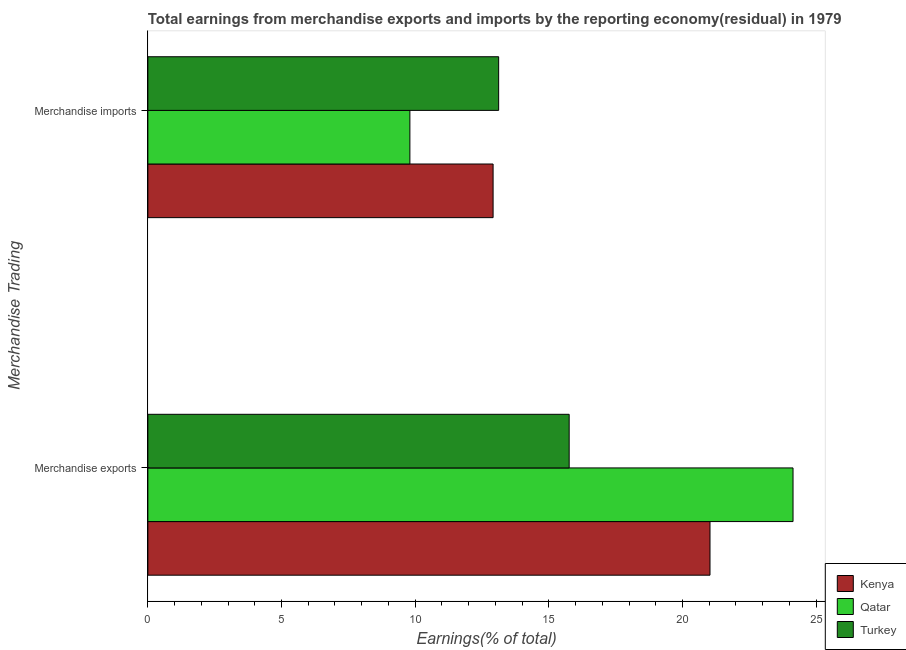How many different coloured bars are there?
Provide a succinct answer. 3. How many groups of bars are there?
Provide a succinct answer. 2. How many bars are there on the 1st tick from the top?
Make the answer very short. 3. What is the earnings from merchandise exports in Qatar?
Your answer should be compact. 24.14. Across all countries, what is the maximum earnings from merchandise imports?
Offer a very short reply. 13.12. Across all countries, what is the minimum earnings from merchandise exports?
Your answer should be very brief. 15.76. In which country was the earnings from merchandise exports maximum?
Offer a terse response. Qatar. In which country was the earnings from merchandise imports minimum?
Keep it short and to the point. Qatar. What is the total earnings from merchandise imports in the graph?
Your response must be concise. 35.84. What is the difference between the earnings from merchandise exports in Turkey and that in Kenya?
Your answer should be very brief. -5.27. What is the difference between the earnings from merchandise exports in Turkey and the earnings from merchandise imports in Qatar?
Make the answer very short. 5.96. What is the average earnings from merchandise exports per country?
Your answer should be very brief. 20.31. What is the difference between the earnings from merchandise exports and earnings from merchandise imports in Qatar?
Provide a succinct answer. 14.33. What is the ratio of the earnings from merchandise exports in Kenya to that in Qatar?
Your answer should be compact. 0.87. In how many countries, is the earnings from merchandise exports greater than the average earnings from merchandise exports taken over all countries?
Offer a terse response. 2. What does the 3rd bar from the top in Merchandise imports represents?
Make the answer very short. Kenya. What does the 3rd bar from the bottom in Merchandise imports represents?
Provide a short and direct response. Turkey. How many countries are there in the graph?
Give a very brief answer. 3. What is the difference between two consecutive major ticks on the X-axis?
Your response must be concise. 5. How are the legend labels stacked?
Keep it short and to the point. Vertical. What is the title of the graph?
Keep it short and to the point. Total earnings from merchandise exports and imports by the reporting economy(residual) in 1979. Does "Sub-Saharan Africa (developing only)" appear as one of the legend labels in the graph?
Your answer should be compact. No. What is the label or title of the X-axis?
Your answer should be compact. Earnings(% of total). What is the label or title of the Y-axis?
Give a very brief answer. Merchandise Trading. What is the Earnings(% of total) of Kenya in Merchandise exports?
Ensure brevity in your answer.  21.03. What is the Earnings(% of total) of Qatar in Merchandise exports?
Offer a very short reply. 24.14. What is the Earnings(% of total) of Turkey in Merchandise exports?
Your response must be concise. 15.76. What is the Earnings(% of total) of Kenya in Merchandise imports?
Offer a very short reply. 12.92. What is the Earnings(% of total) in Qatar in Merchandise imports?
Keep it short and to the point. 9.8. What is the Earnings(% of total) of Turkey in Merchandise imports?
Provide a short and direct response. 13.12. Across all Merchandise Trading, what is the maximum Earnings(% of total) in Kenya?
Give a very brief answer. 21.03. Across all Merchandise Trading, what is the maximum Earnings(% of total) of Qatar?
Ensure brevity in your answer.  24.14. Across all Merchandise Trading, what is the maximum Earnings(% of total) in Turkey?
Ensure brevity in your answer.  15.76. Across all Merchandise Trading, what is the minimum Earnings(% of total) of Kenya?
Keep it short and to the point. 12.92. Across all Merchandise Trading, what is the minimum Earnings(% of total) of Qatar?
Provide a short and direct response. 9.8. Across all Merchandise Trading, what is the minimum Earnings(% of total) of Turkey?
Provide a short and direct response. 13.12. What is the total Earnings(% of total) of Kenya in the graph?
Ensure brevity in your answer.  33.95. What is the total Earnings(% of total) of Qatar in the graph?
Provide a succinct answer. 33.94. What is the total Earnings(% of total) in Turkey in the graph?
Your answer should be compact. 28.88. What is the difference between the Earnings(% of total) in Kenya in Merchandise exports and that in Merchandise imports?
Your answer should be very brief. 8.11. What is the difference between the Earnings(% of total) in Qatar in Merchandise exports and that in Merchandise imports?
Make the answer very short. 14.33. What is the difference between the Earnings(% of total) of Turkey in Merchandise exports and that in Merchandise imports?
Your answer should be very brief. 2.64. What is the difference between the Earnings(% of total) in Kenya in Merchandise exports and the Earnings(% of total) in Qatar in Merchandise imports?
Your answer should be very brief. 11.23. What is the difference between the Earnings(% of total) in Kenya in Merchandise exports and the Earnings(% of total) in Turkey in Merchandise imports?
Provide a succinct answer. 7.91. What is the difference between the Earnings(% of total) of Qatar in Merchandise exports and the Earnings(% of total) of Turkey in Merchandise imports?
Keep it short and to the point. 11.01. What is the average Earnings(% of total) of Kenya per Merchandise Trading?
Ensure brevity in your answer.  16.97. What is the average Earnings(% of total) in Qatar per Merchandise Trading?
Provide a succinct answer. 16.97. What is the average Earnings(% of total) in Turkey per Merchandise Trading?
Your answer should be compact. 14.44. What is the difference between the Earnings(% of total) of Kenya and Earnings(% of total) of Qatar in Merchandise exports?
Provide a succinct answer. -3.11. What is the difference between the Earnings(% of total) of Kenya and Earnings(% of total) of Turkey in Merchandise exports?
Provide a succinct answer. 5.27. What is the difference between the Earnings(% of total) in Qatar and Earnings(% of total) in Turkey in Merchandise exports?
Provide a succinct answer. 8.38. What is the difference between the Earnings(% of total) of Kenya and Earnings(% of total) of Qatar in Merchandise imports?
Keep it short and to the point. 3.11. What is the difference between the Earnings(% of total) in Kenya and Earnings(% of total) in Turkey in Merchandise imports?
Your answer should be very brief. -0.21. What is the difference between the Earnings(% of total) of Qatar and Earnings(% of total) of Turkey in Merchandise imports?
Keep it short and to the point. -3.32. What is the ratio of the Earnings(% of total) in Kenya in Merchandise exports to that in Merchandise imports?
Provide a short and direct response. 1.63. What is the ratio of the Earnings(% of total) of Qatar in Merchandise exports to that in Merchandise imports?
Provide a short and direct response. 2.46. What is the ratio of the Earnings(% of total) in Turkey in Merchandise exports to that in Merchandise imports?
Make the answer very short. 1.2. What is the difference between the highest and the second highest Earnings(% of total) of Kenya?
Your response must be concise. 8.11. What is the difference between the highest and the second highest Earnings(% of total) of Qatar?
Provide a short and direct response. 14.33. What is the difference between the highest and the second highest Earnings(% of total) in Turkey?
Your response must be concise. 2.64. What is the difference between the highest and the lowest Earnings(% of total) in Kenya?
Provide a succinct answer. 8.11. What is the difference between the highest and the lowest Earnings(% of total) of Qatar?
Keep it short and to the point. 14.33. What is the difference between the highest and the lowest Earnings(% of total) in Turkey?
Your answer should be compact. 2.64. 